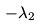Convert formula to latex. <formula><loc_0><loc_0><loc_500><loc_500>- \lambda _ { 2 }</formula> 